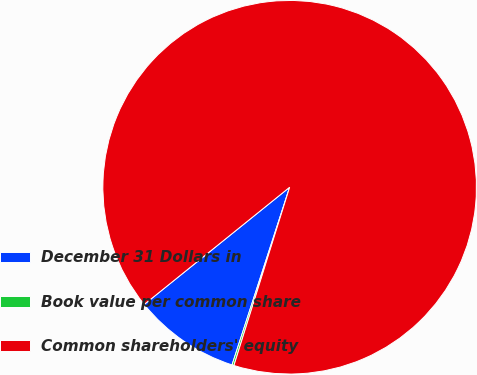<chart> <loc_0><loc_0><loc_500><loc_500><pie_chart><fcel>December 31 Dollars in<fcel>Book value per common share<fcel>Common shareholders' equity<nl><fcel>9.21%<fcel>0.17%<fcel>90.62%<nl></chart> 